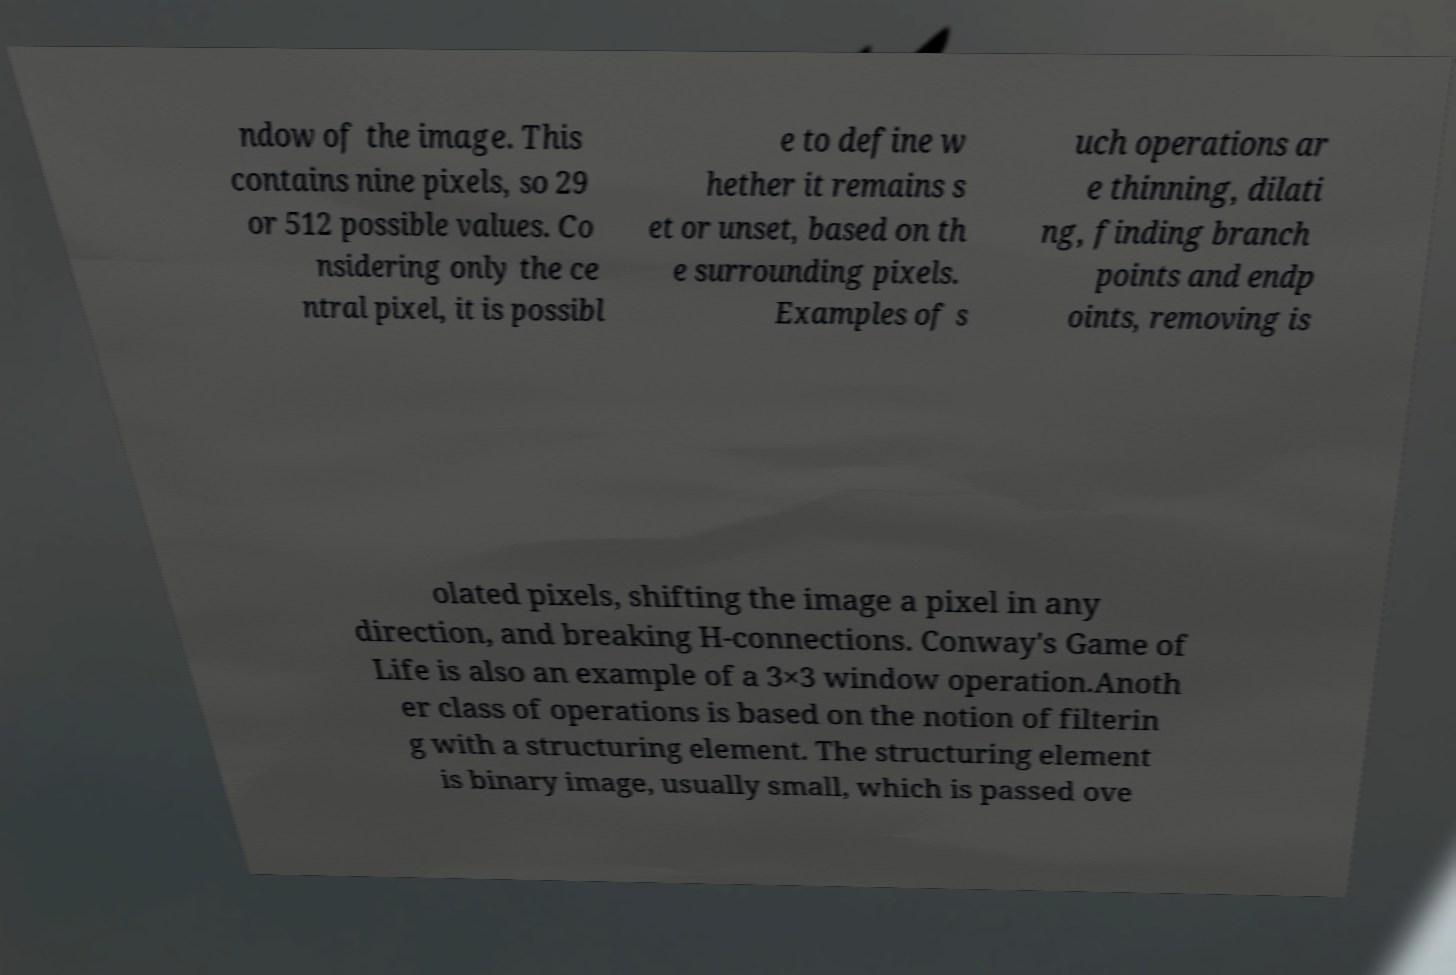I need the written content from this picture converted into text. Can you do that? ndow of the image. This contains nine pixels, so 29 or 512 possible values. Co nsidering only the ce ntral pixel, it is possibl e to define w hether it remains s et or unset, based on th e surrounding pixels. Examples of s uch operations ar e thinning, dilati ng, finding branch points and endp oints, removing is olated pixels, shifting the image a pixel in any direction, and breaking H-connections. Conway's Game of Life is also an example of a 3×3 window operation.Anoth er class of operations is based on the notion of filterin g with a structuring element. The structuring element is binary image, usually small, which is passed ove 